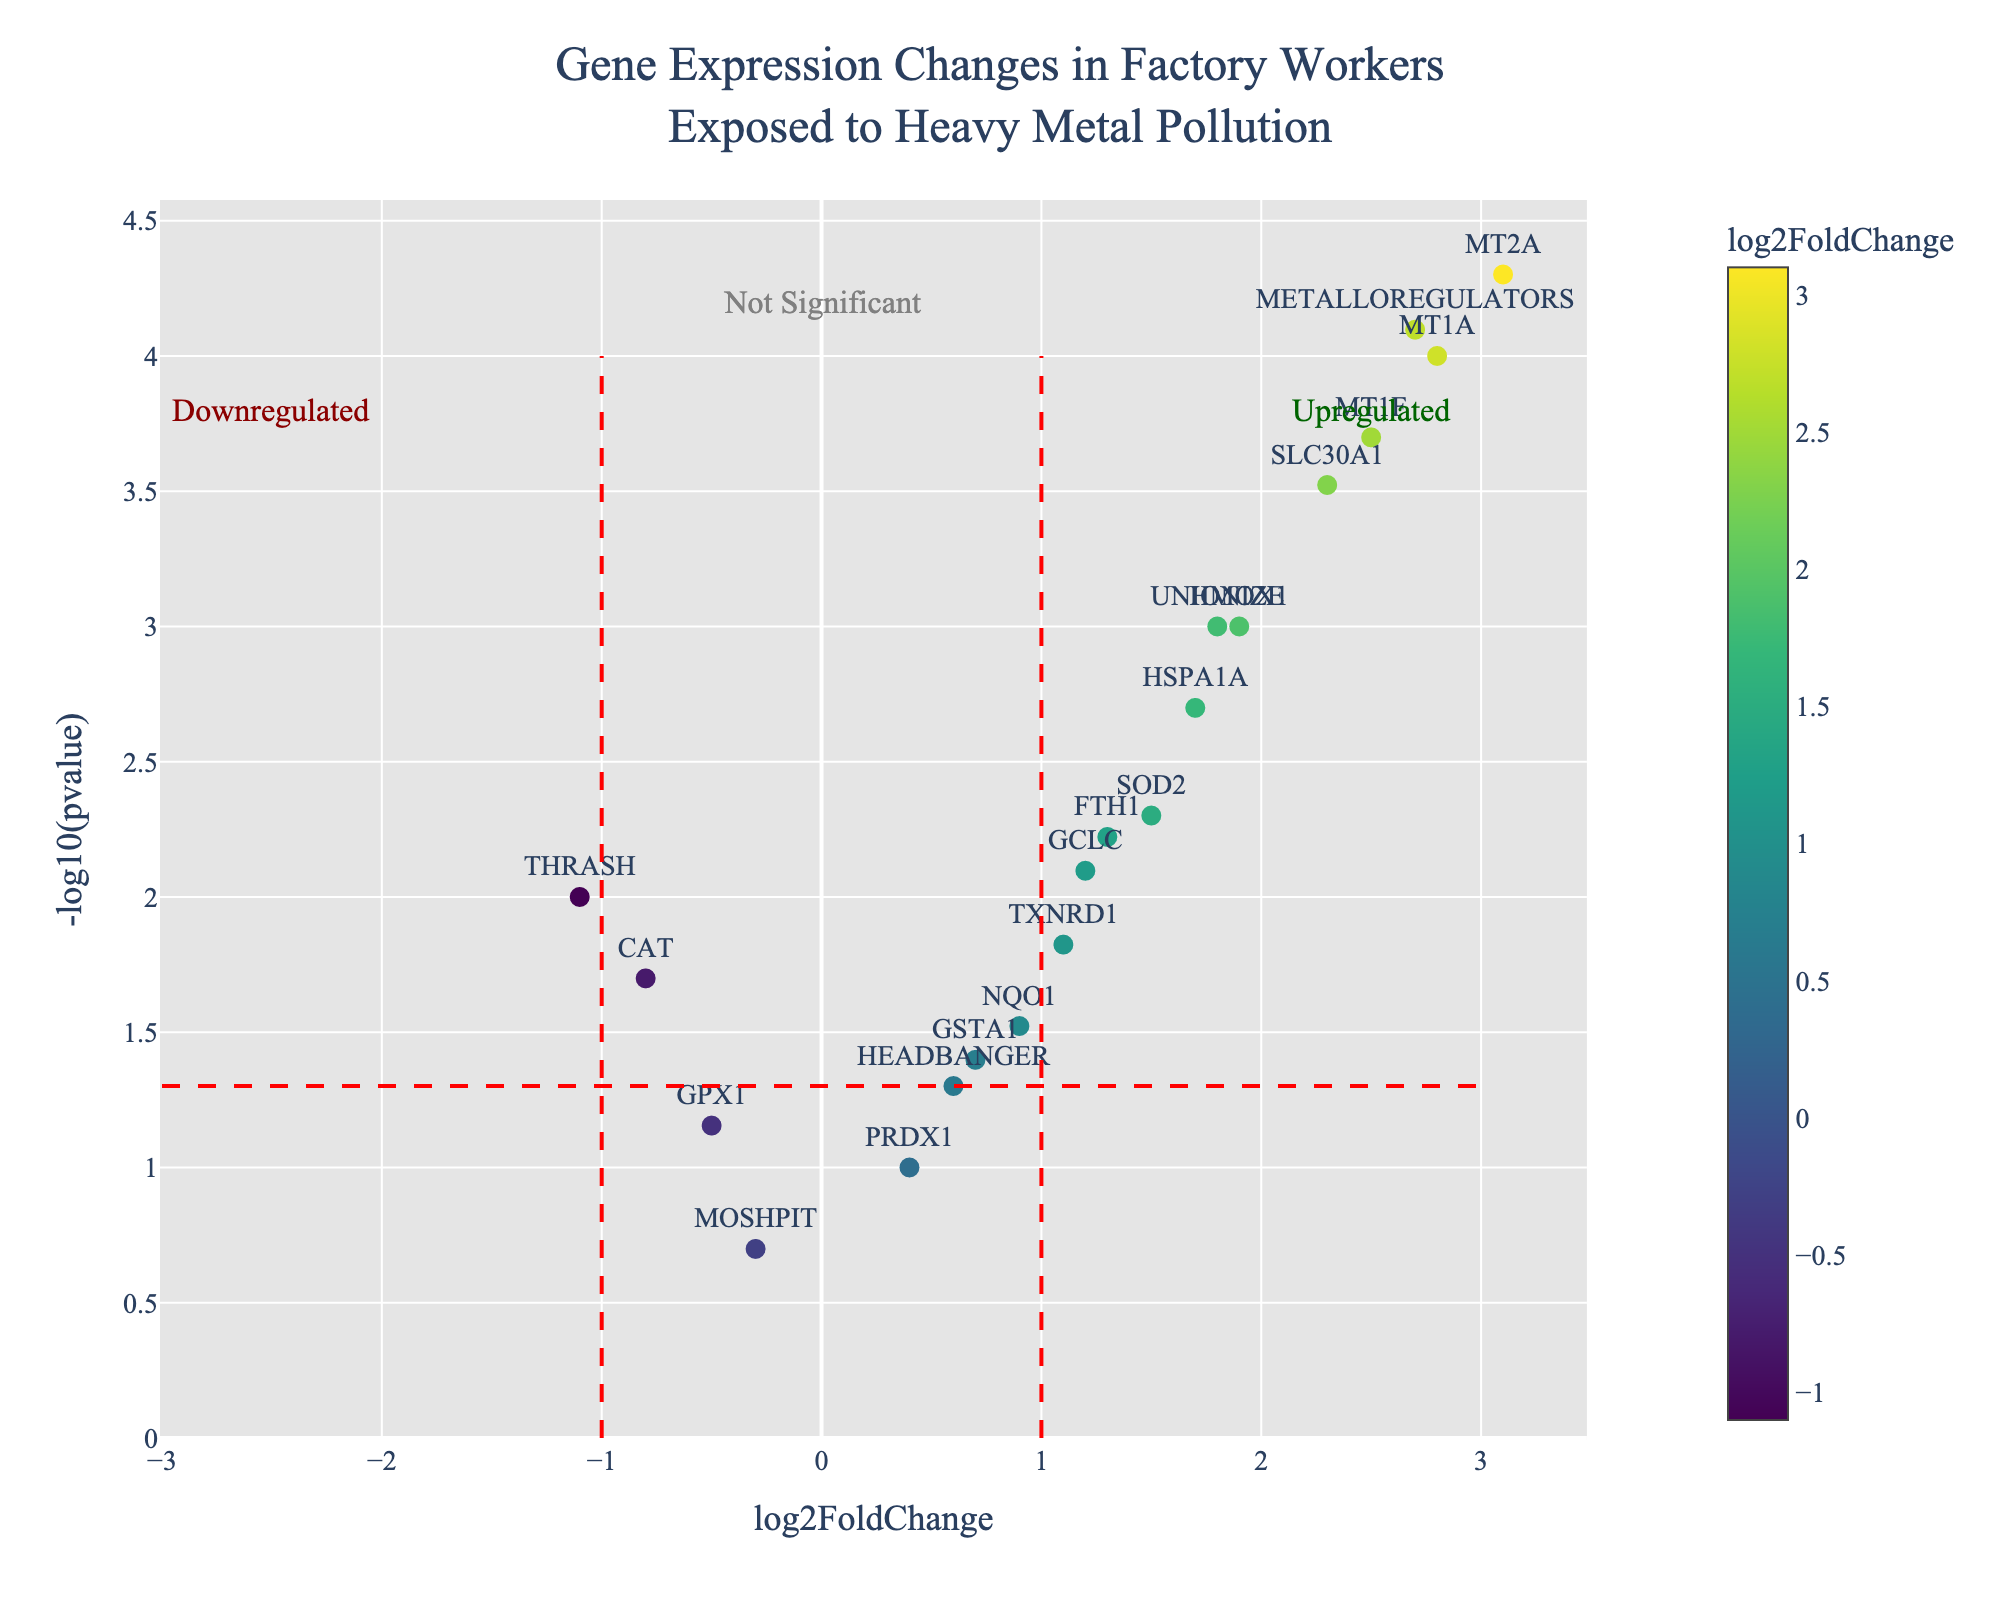How many genes are plotted in the figure? Count the data points present in the scatter plot. By counting, you will find 19 distinct genes in the plot.
Answer: 19 Which gene shows the highest upregulation? Upregulation is indicated by higher log2FoldChange values. Among the plotted genes, MT2A has the highest log2FoldChange value of 3.1.
Answer: MT2A Is the gene HMOX1 statistically significant? Statistical significance is usually marked by points above the horizontal line representing -log10(pvalue) = -log10(0.05). For HMOX1, -log10(0.001) is above this threshold, indicating significance.
Answer: Yes Which gene appears to be the most downregulated? Downregulation is indicated by the most negative log2FoldChange value. Among the plotted genes, THRASH has the lowest log2FoldChange value of -1.1.
Answer: THRASH Which gene has a log2FoldChange around 0.9 and is it significant? Locate the point on the x-axis close to 0.9 and check its position on the -log10(pvalue) axis relative to the horizontal significance line. For gene NQO1, which has log2FoldChange of 0.9, the -log10(pvalue) is below the threshold, making it not significant.
Answer: NQO1, No What is the significance threshold used in the plot? The plot marks significance with a horizontal red dashed line at -log10(pvalue) = -log10(0.05). Calculate the line position, which is -log10(0.05) ≈ 1.3.
Answer: 1.3 How many genes are upregulated and significant? Upregulated genes are to the right of the right vertical line and above the horizontal line. Count these points, there are 11 upregulated and significant genes (MT1A, MT2A, HMOX1, SOD2, GCLC, TXNRD1, SLC30A1, MT1F, HSPA1A, FTH1, UNIONIZE).
Answer: 11 Compare the fold changes of METALLOREGULATORS and UNIONIZE. Which gene has a higher value? Check the log2FoldChange for both genes. METALLOREGULATORS has a log2FoldChange of 2.7, while UNIONIZE has 1.8. Hence, METALLOREGULATORS has the higher value.
Answer: METALLOREGULATORS What is the general trend observed for genes with a log2FoldChange higher than 1? Identify points with log2FoldChange >1 and check their corresponding -log10(pvalues). All these points are above the significance threshold, indicating that genes with log2FoldChange >1 are generally significant.
Answer: Significant Identify the gene with a log2FoldChange of approximately 2.8 and determine its significance. Locate the point near log2FoldChange of 2.8. For gene MT1A, with log2FoldChange of 2.8, the -log10(pvalue) is well above the threshold, indicating significant upregulation.
Answer: MT1A, Significant 